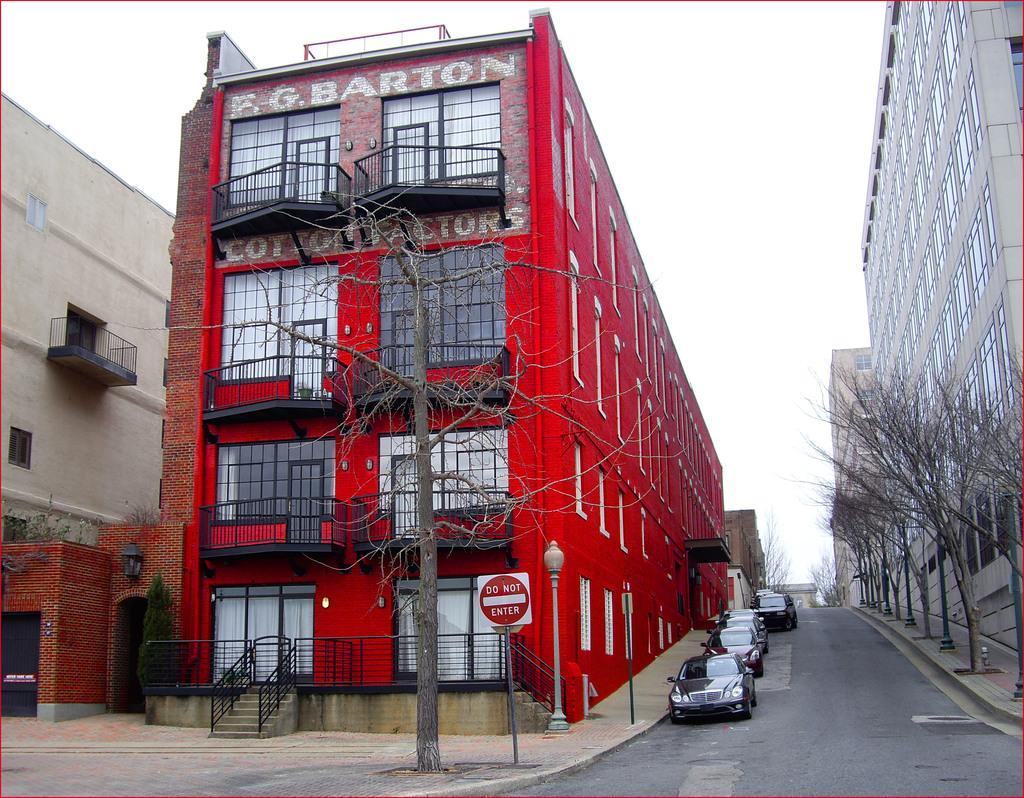Could you give a brief overview of what you see in this image? In the center of the image there is a building. There are cars. There are trees. 